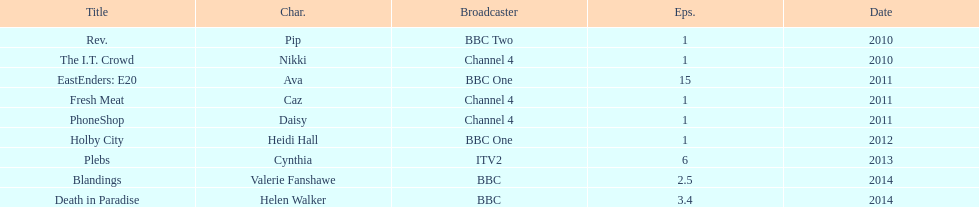Which broadcaster hosted 3 titles but they had only 1 episode? Channel 4. 